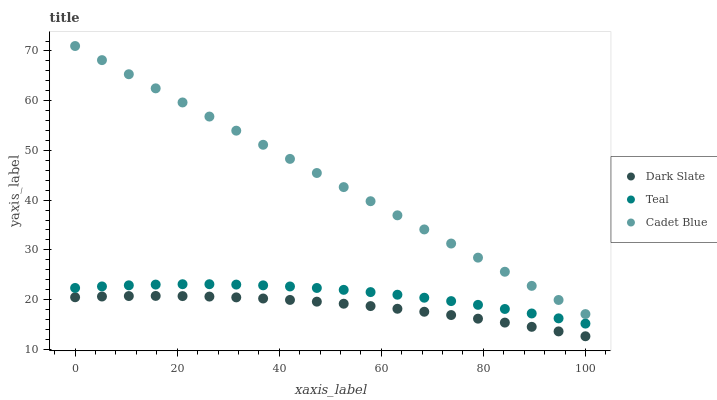Does Dark Slate have the minimum area under the curve?
Answer yes or no. Yes. Does Cadet Blue have the maximum area under the curve?
Answer yes or no. Yes. Does Teal have the minimum area under the curve?
Answer yes or no. No. Does Teal have the maximum area under the curve?
Answer yes or no. No. Is Cadet Blue the smoothest?
Answer yes or no. Yes. Is Teal the roughest?
Answer yes or no. Yes. Is Teal the smoothest?
Answer yes or no. No. Is Cadet Blue the roughest?
Answer yes or no. No. Does Dark Slate have the lowest value?
Answer yes or no. Yes. Does Teal have the lowest value?
Answer yes or no. No. Does Cadet Blue have the highest value?
Answer yes or no. Yes. Does Teal have the highest value?
Answer yes or no. No. Is Teal less than Cadet Blue?
Answer yes or no. Yes. Is Cadet Blue greater than Dark Slate?
Answer yes or no. Yes. Does Teal intersect Cadet Blue?
Answer yes or no. No. 